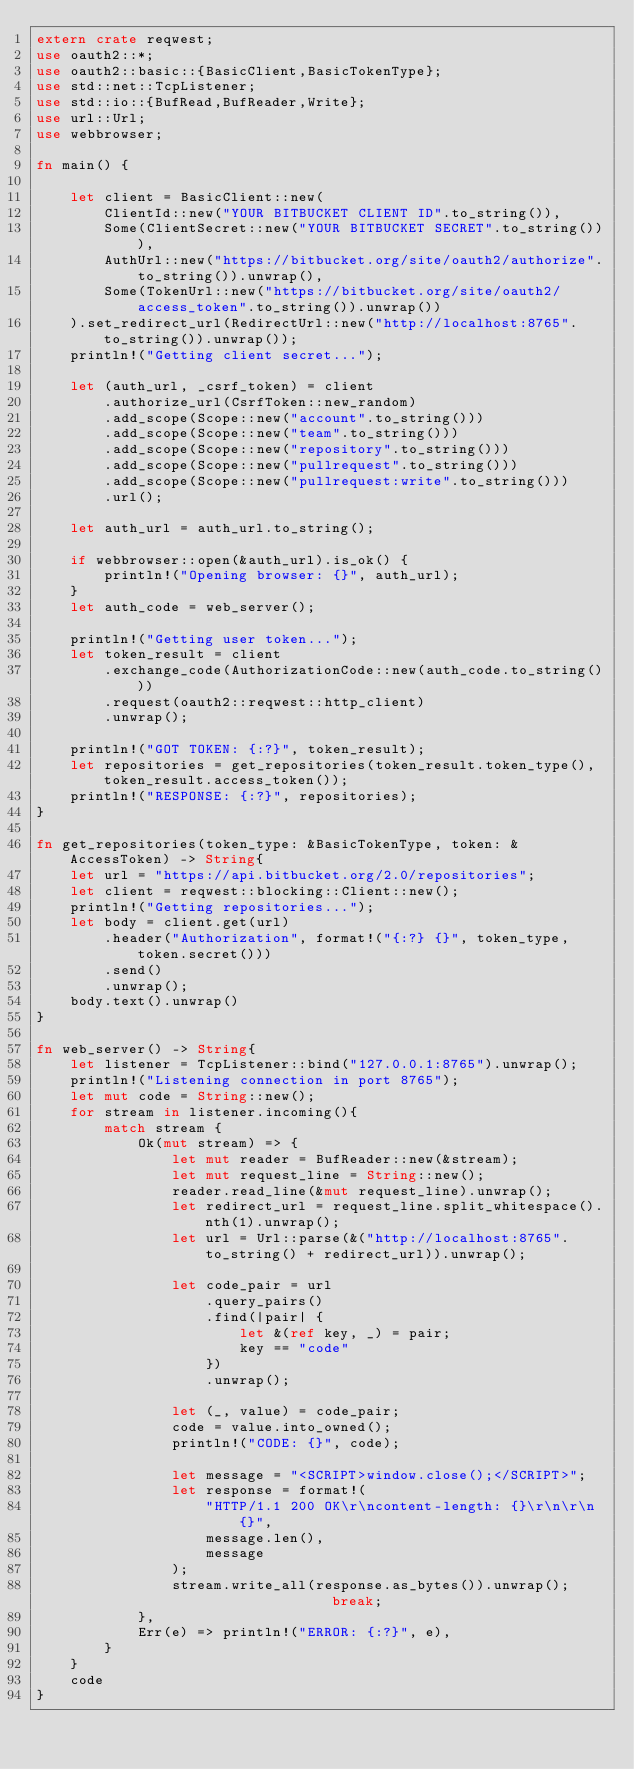Convert code to text. <code><loc_0><loc_0><loc_500><loc_500><_Rust_>extern crate reqwest;
use oauth2::*;
use oauth2::basic::{BasicClient,BasicTokenType};
use std::net::TcpListener;
use std::io::{BufRead,BufReader,Write};
use url::Url;
use webbrowser;

fn main() {
    
    let client = BasicClient::new(
        ClientId::new("YOUR BITBUCKET CLIENT ID".to_string()),
        Some(ClientSecret::new("YOUR BITBUCKET SECRET".to_string())),
        AuthUrl::new("https://bitbucket.org/site/oauth2/authorize".to_string()).unwrap(),
        Some(TokenUrl::new("https://bitbucket.org/site/oauth2/access_token".to_string()).unwrap())
    ).set_redirect_url(RedirectUrl::new("http://localhost:8765".to_string()).unwrap());
    println!("Getting client secret...");

    let (auth_url, _csrf_token) = client
        .authorize_url(CsrfToken::new_random)
        .add_scope(Scope::new("account".to_string()))
        .add_scope(Scope::new("team".to_string()))
        .add_scope(Scope::new("repository".to_string()))
        .add_scope(Scope::new("pullrequest".to_string()))
        .add_scope(Scope::new("pullrequest:write".to_string()))
        .url();

    let auth_url = auth_url.to_string();

    if webbrowser::open(&auth_url).is_ok() {
        println!("Opening browser: {}", auth_url);
    }
    let auth_code = web_server();

    println!("Getting user token...");
    let token_result = client
        .exchange_code(AuthorizationCode::new(auth_code.to_string()))
        .request(oauth2::reqwest::http_client)
        .unwrap();

    println!("GOT TOKEN: {:?}", token_result);
    let repositories = get_repositories(token_result.token_type(), token_result.access_token());
    println!("RESPONSE: {:?}", repositories);
}

fn get_repositories(token_type: &BasicTokenType, token: &AccessToken) -> String{
    let url = "https://api.bitbucket.org/2.0/repositories";
    let client = reqwest::blocking::Client::new();
    println!("Getting repositories...");
    let body = client.get(url)
        .header("Authorization", format!("{:?} {}", token_type, token.secret()))
        .send()
        .unwrap();
    body.text().unwrap()
}

fn web_server() -> String{
    let listener = TcpListener::bind("127.0.0.1:8765").unwrap();
    println!("Listening connection in port 8765");
    let mut code = String::new();
    for stream in listener.incoming(){
        match stream {
            Ok(mut stream) => {
                let mut reader = BufReader::new(&stream);
                let mut request_line = String::new();
                reader.read_line(&mut request_line).unwrap();
                let redirect_url = request_line.split_whitespace().nth(1).unwrap();
                let url = Url::parse(&("http://localhost:8765".to_string() + redirect_url)).unwrap();

                let code_pair = url
                    .query_pairs()
                    .find(|pair| {
                        let &(ref key, _) = pair;
                        key == "code"
                    })
                    .unwrap();

                let (_, value) = code_pair;
                code = value.into_owned();
                println!("CODE: {}", code);

                let message = "<SCRIPT>window.close();</SCRIPT>";
                let response = format!(
                    "HTTP/1.1 200 OK\r\ncontent-length: {}\r\n\r\n{}",
                    message.len(),
                    message
                );
                stream.write_all(response.as_bytes()).unwrap();                break;
            },
            Err(e) => println!("ERROR: {:?}", e),
        }
    }
    code
}</code> 